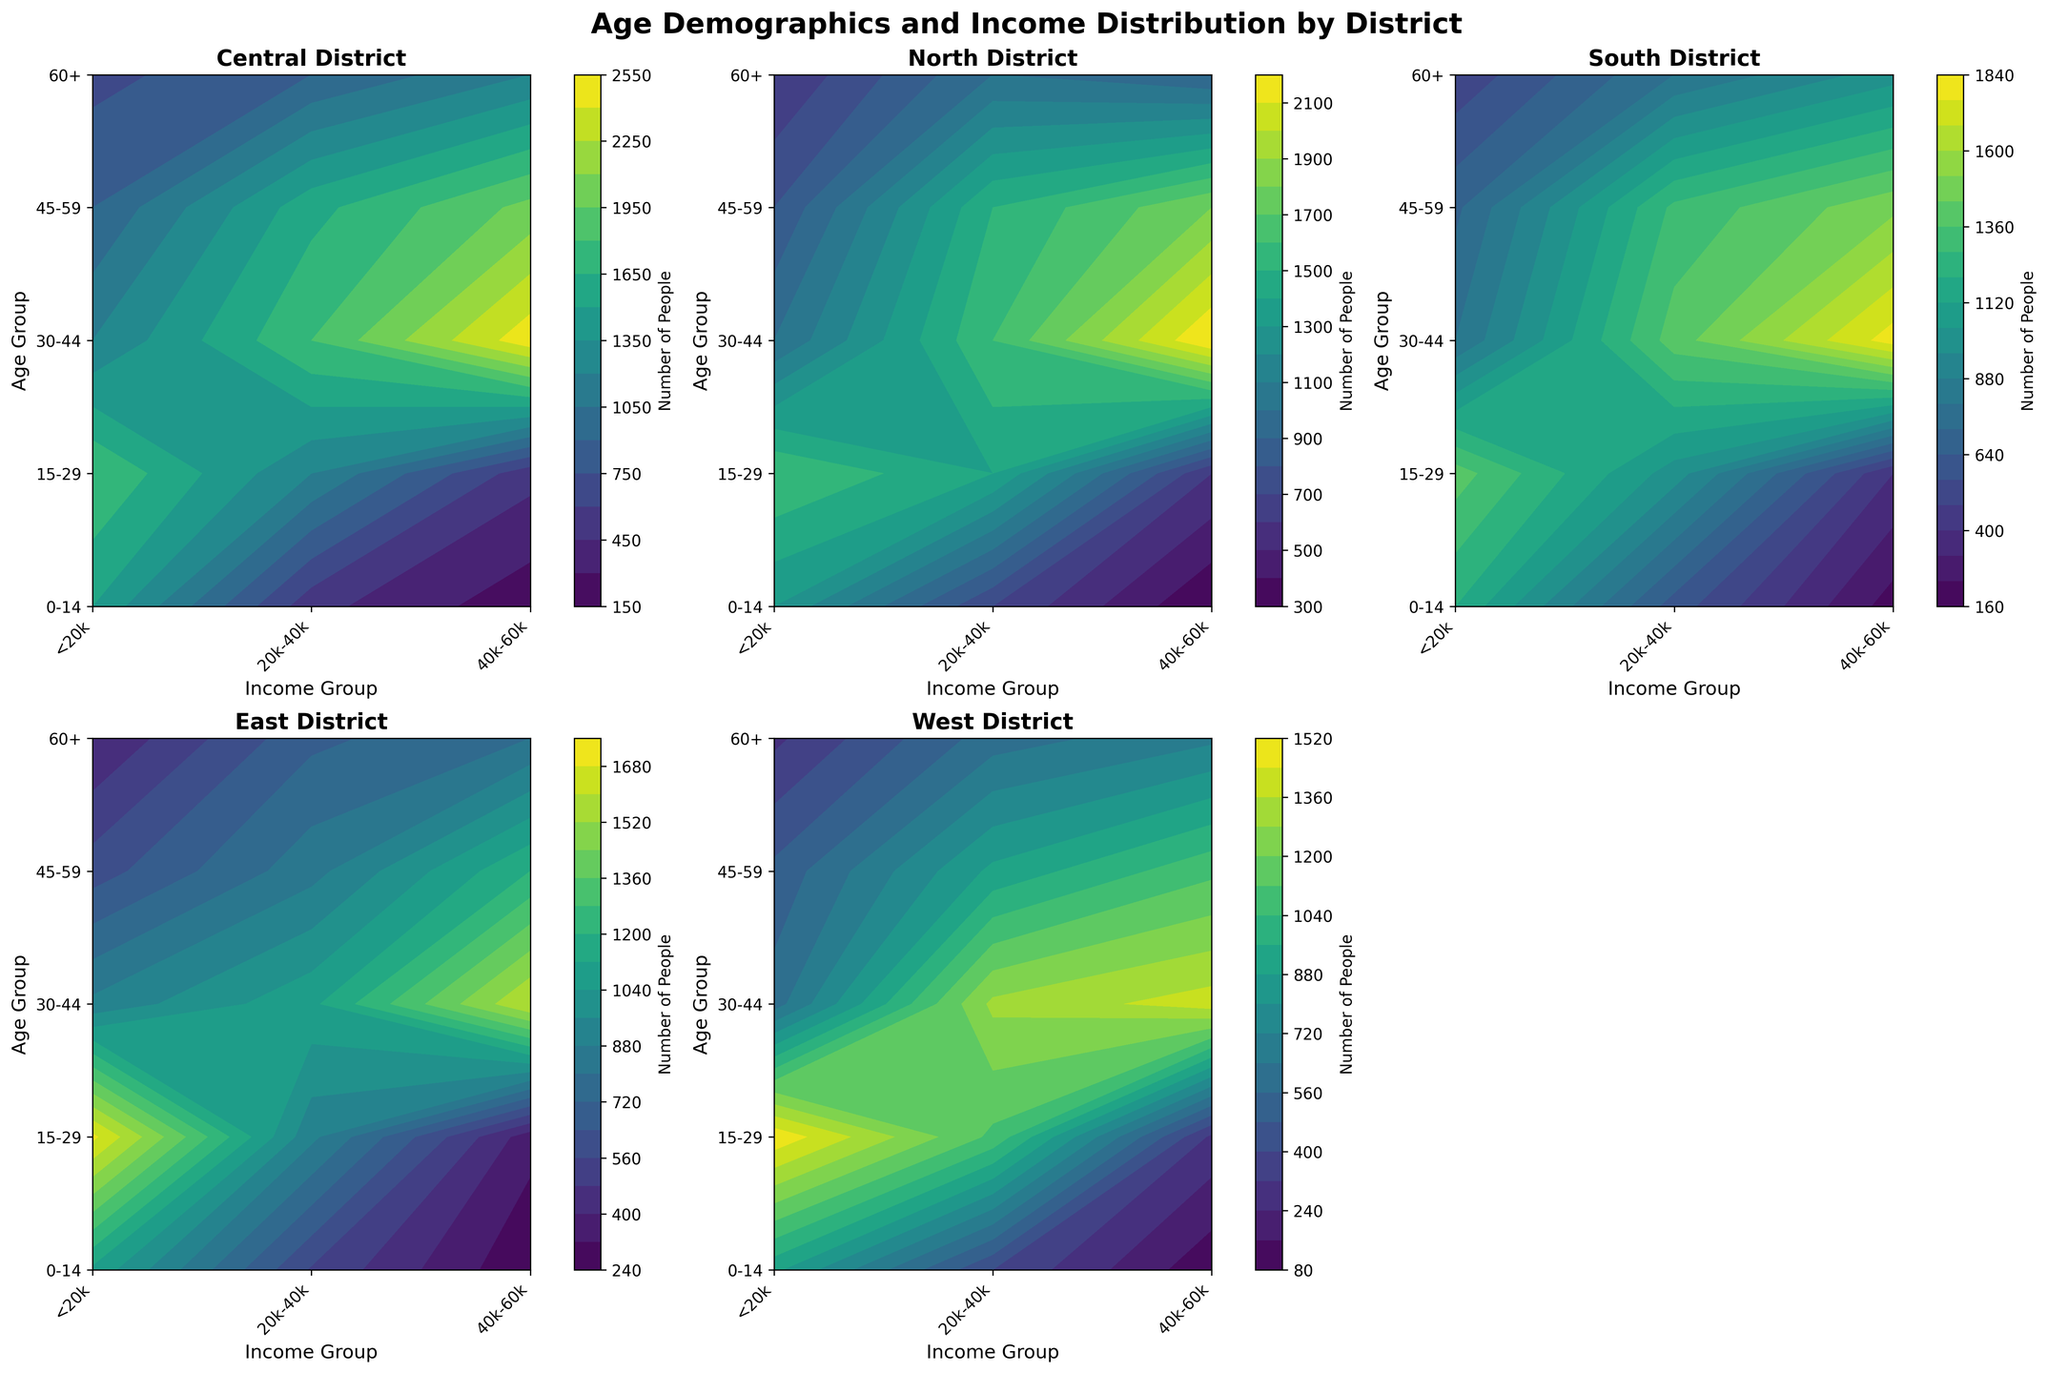What is the title of the figure? The title is found at the top of the figure in a bold font. It typically provides a summary or indication of what the figure represents. In this case, the title is "Age Demographics and Income Distribution by District."
Answer: Age Demographics and Income Distribution by District Which district has the highest number of people in the 30-44 age group earning 40k-60k? To answer this, locate the 30-44 age group on the y-axis, then find the 40k-60k income group on the x-axis. Compare the contour levels (colors) across different district subplots to determine which one has the highest value. The Central district shows the highest density in this group.
Answer: Central What age group has the lowest number of people in the South district? For the South district, compare the contour levels across different age groups. The contours for the age group 60+ show the least dense regions.
Answer: 60+ Which income group in the East district has more people in the 15-29 age range: <20k or 20k-40k? Look at the sub-plot for the East district, locate the 15-29 age group on the y-axis and compare the contour levels for <20k and 20k-40k income groups on the x-axis. The <20k income group has a denser contour level than the 20k-40k income group.
Answer: <20k How does the number of people in the 0-14 age group earning <20k compare between the North and West districts? Compare the contour levels for the 0-14 age group and <20k income group in the North and West district subplots. The North district has a denser contour level than the West district in this category.
Answer: North In which district is the distribution of people across all age groups and income levels the most uniform? Examine the contour plots for each district to see which one displays the most even spread of contour levels across different age groups and income levels. The West district shows a relatively uniform distribution compared to others.
Answer: West What is the income group with the highest number of people aged 60+ in the Central district? In the Central district subplot, locate the 60+ age group on the y-axis and identify which income group on the x-axis has the highest contour level. The 40k-60k group has the highest contour density for the 60+ age group.
Answer: 40k-60k Which district has the fewest number of people in the 15-29 age group earning 40k-60k? Compare the 15-29 age groups earning 40k-60k across all districts by analyzing the contour levels. The East district shows the lowest density in this group.
Answer: East What age group is most populous in the North district? Locate the North district subplot and compare the contour levels across all age groups. The 15-29 age group shows the highest density contours.
Answer: 15-29 